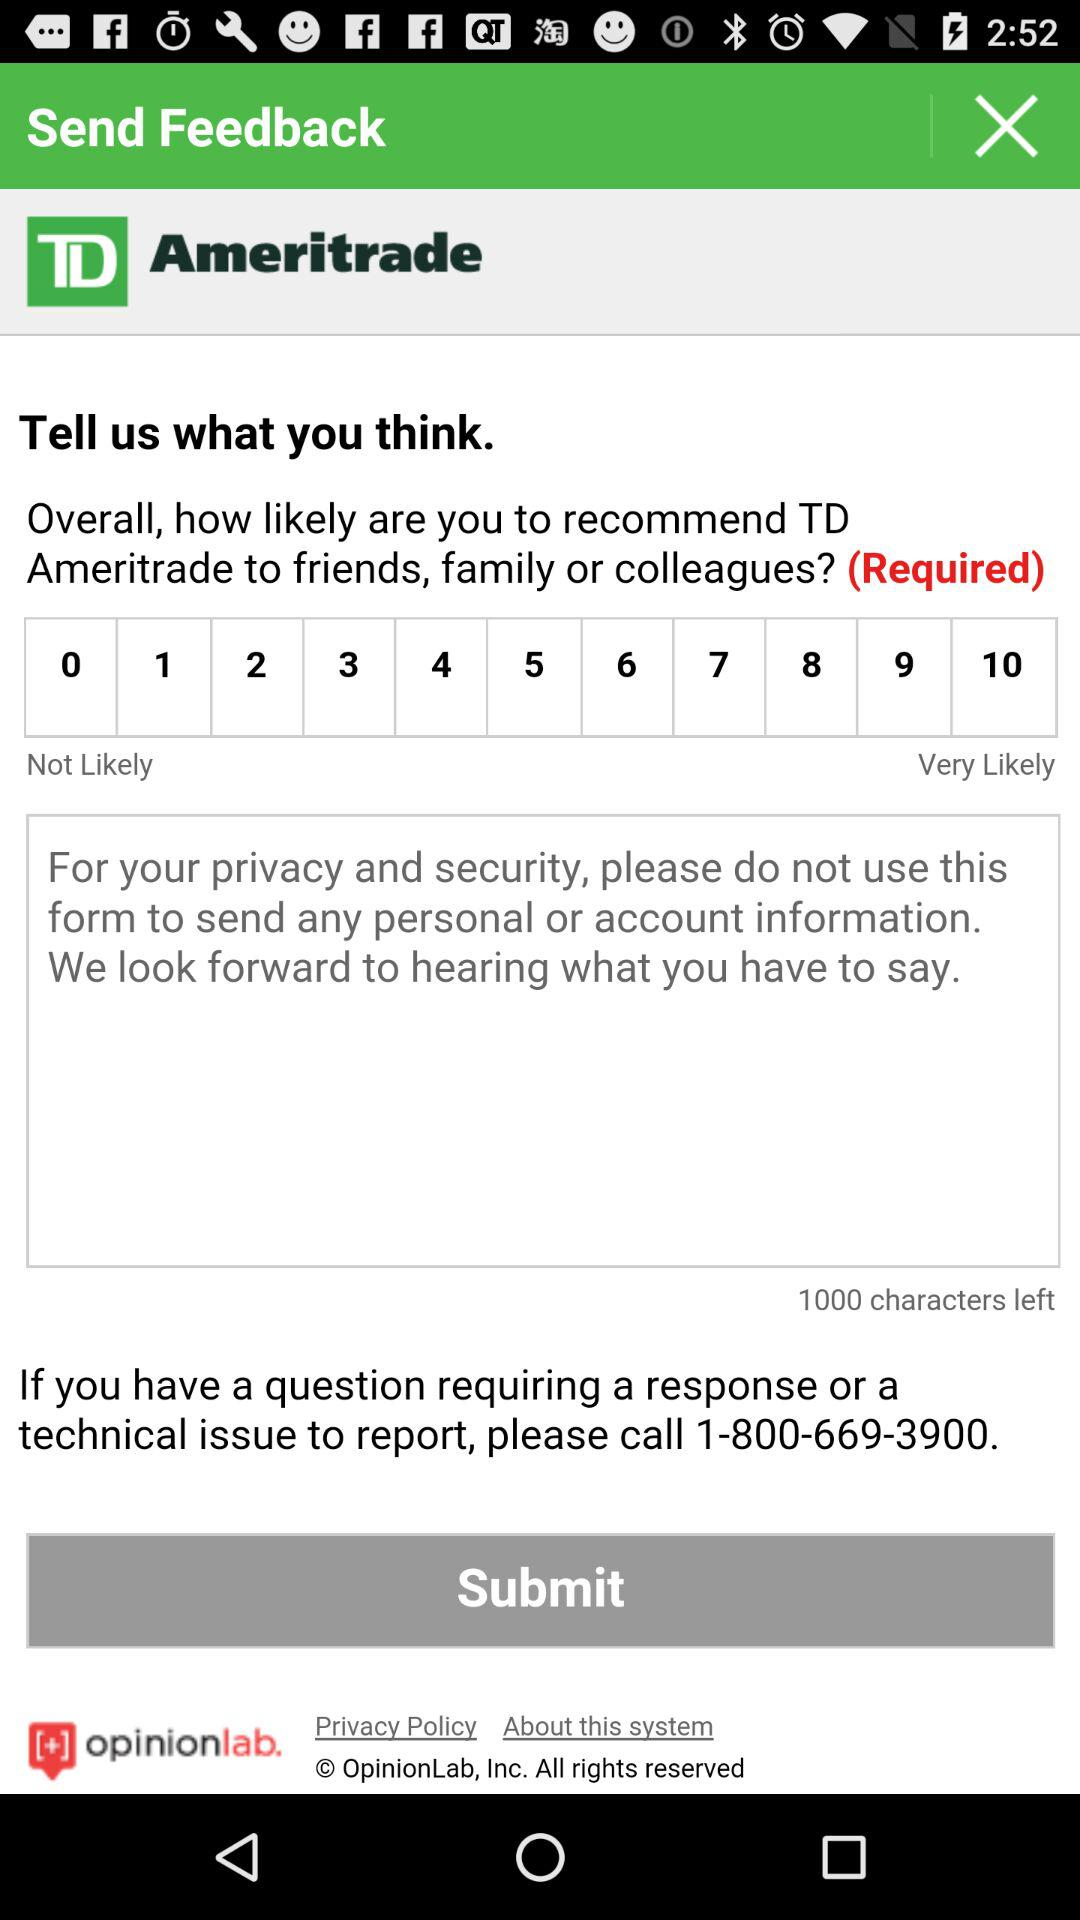Which phone number is there to report a technical issue? The phone number is 1-800-669-3900. 